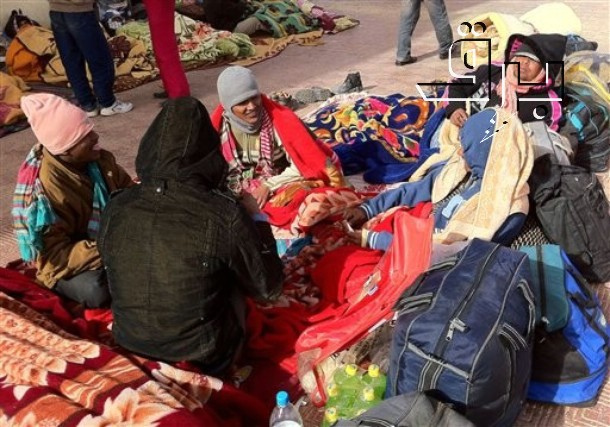Imagine these individuals are part of a theater troupe, taking a break between rehearsals. How would you describe their break time? This theater troupe, known for their innovative street performances, takes a well-deserved break between rehearsals. Wrapped in colorful scarves and layers of winter clothing to combat the chilly weather, they sit in a circle, exchanging ideas and laughs. The ground, covered in vibrant, eclectic blankets and props, represents their creativity and flair. Bottles of water, a red bag full of snacks, and a mixture of costumes and personal items scattered around adds to the atmosphere of organized chaos. As they share stories and plan their next act, there’s an undeniable energy and bond that shines through, demonstrating their commitment to their craft and to each other. 